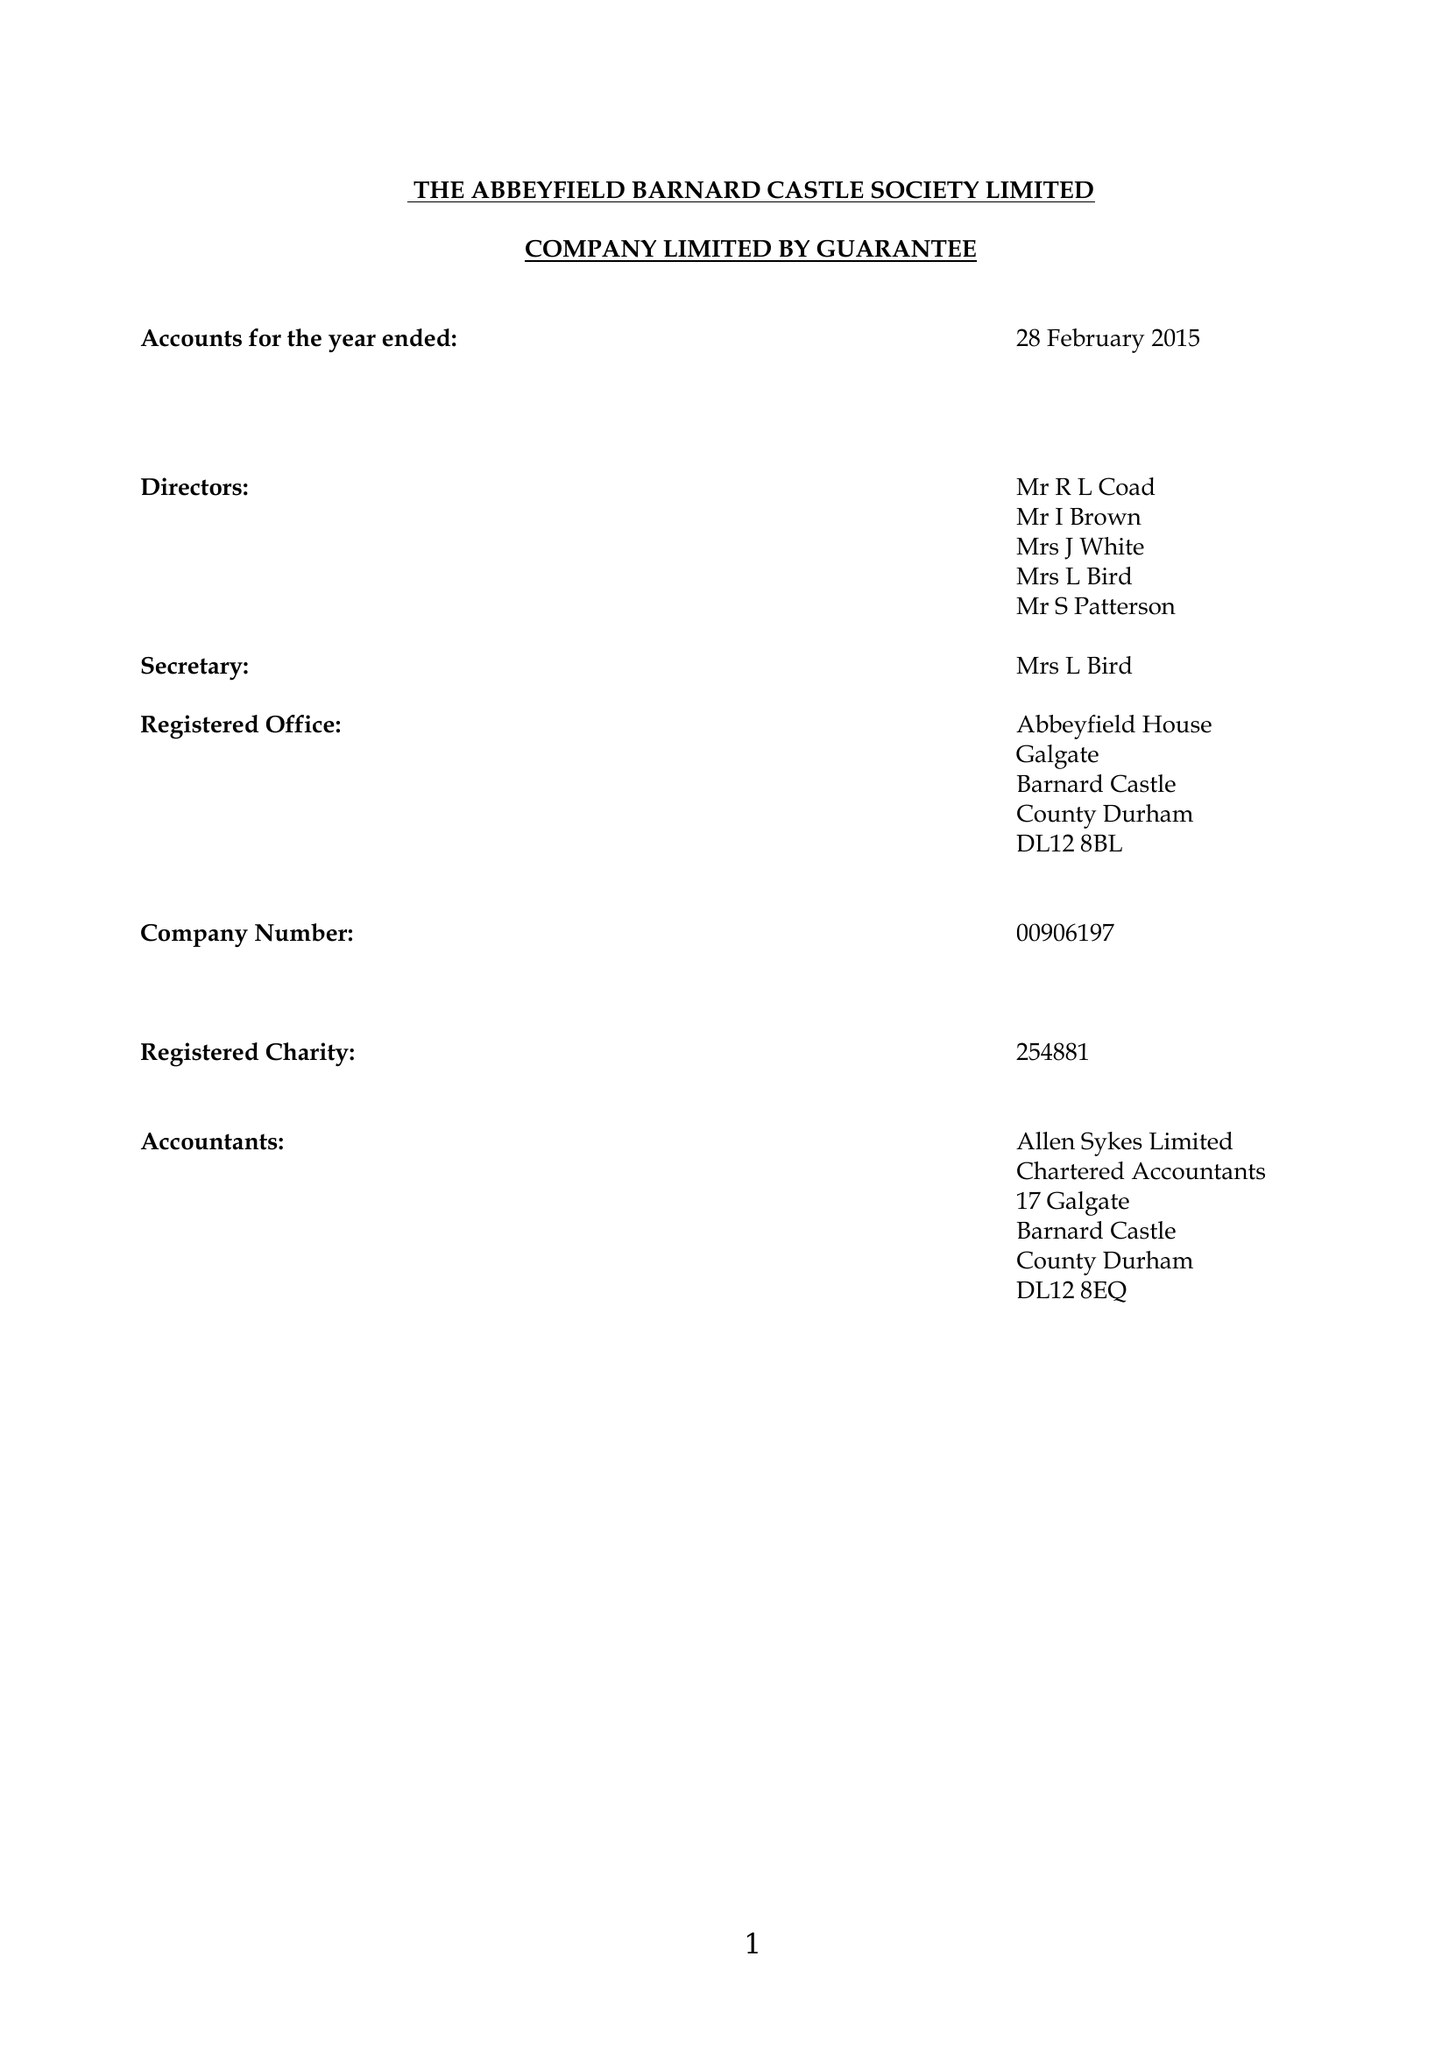What is the value for the income_annually_in_british_pounds?
Answer the question using a single word or phrase. 169141.00 